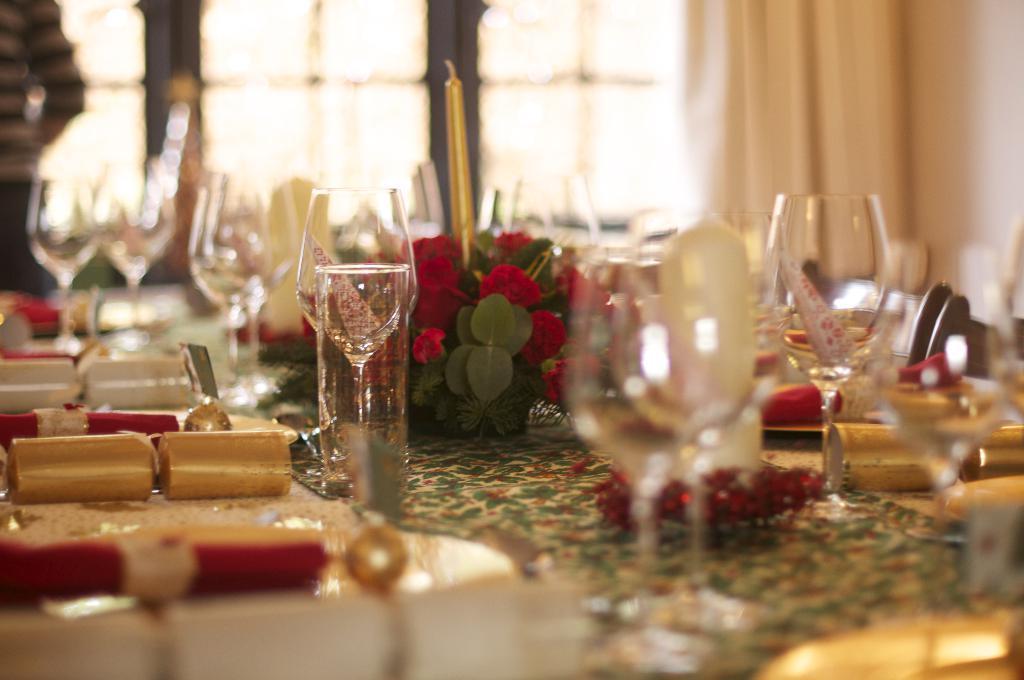How would you summarize this image in a sentence or two? In this picture here we can see a table. On the table, we have glasses present and also flower bouquet is present, candle present on the table. In the background we can see window, window curtain and wall. Here we can see a person standing. 